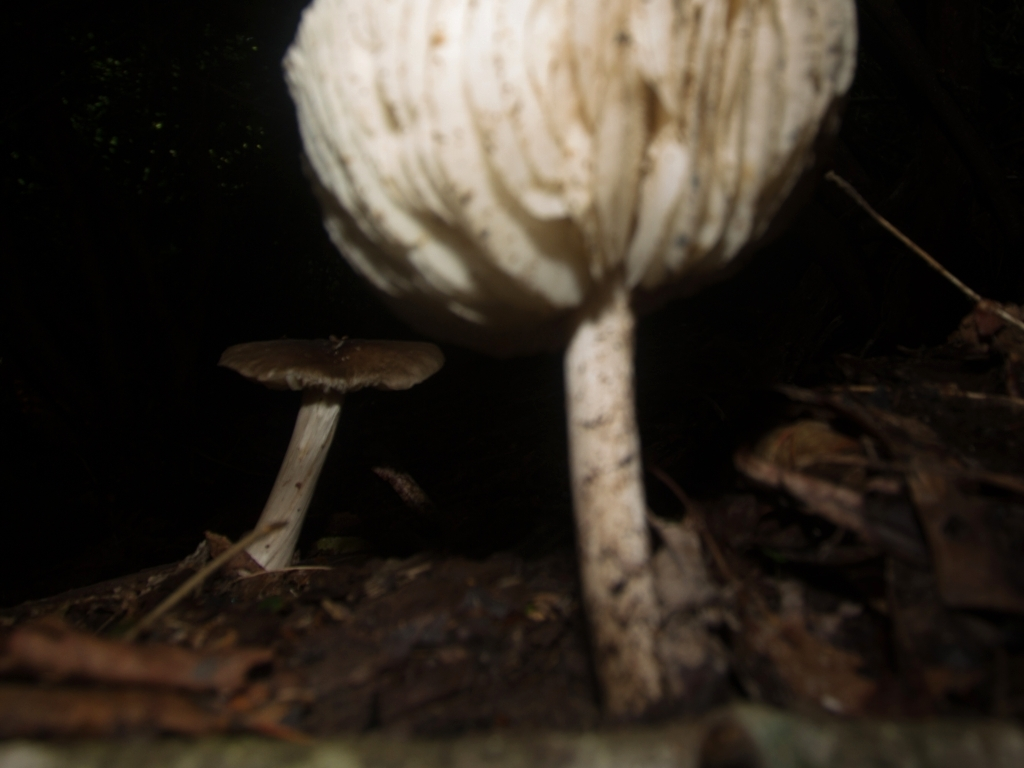Are there any quality issues with this image? Yes, the image suffers from several quality issues. The most prominent problem is the lack of focus; the image is blurry which prevents a clear view of the details of the mushrooms and the surrounding environment. Additionally, the lighting appears to be poorly balanced, with the foreground significantly underexposed compared to the background, resulting in lost details in the shadows. The composition might also be improved for better aesthetic appeal. 